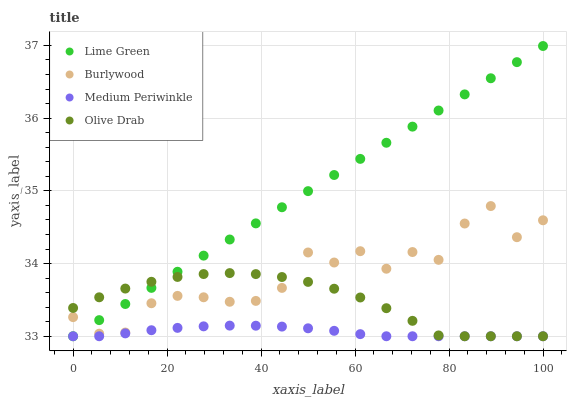Does Medium Periwinkle have the minimum area under the curve?
Answer yes or no. Yes. Does Lime Green have the maximum area under the curve?
Answer yes or no. Yes. Does Lime Green have the minimum area under the curve?
Answer yes or no. No. Does Medium Periwinkle have the maximum area under the curve?
Answer yes or no. No. Is Lime Green the smoothest?
Answer yes or no. Yes. Is Burlywood the roughest?
Answer yes or no. Yes. Is Medium Periwinkle the smoothest?
Answer yes or no. No. Is Medium Periwinkle the roughest?
Answer yes or no. No. Does Medium Periwinkle have the lowest value?
Answer yes or no. Yes. Does Lime Green have the highest value?
Answer yes or no. Yes. Does Medium Periwinkle have the highest value?
Answer yes or no. No. Is Medium Periwinkle less than Burlywood?
Answer yes or no. Yes. Is Burlywood greater than Medium Periwinkle?
Answer yes or no. Yes. Does Lime Green intersect Olive Drab?
Answer yes or no. Yes. Is Lime Green less than Olive Drab?
Answer yes or no. No. Is Lime Green greater than Olive Drab?
Answer yes or no. No. Does Medium Periwinkle intersect Burlywood?
Answer yes or no. No. 